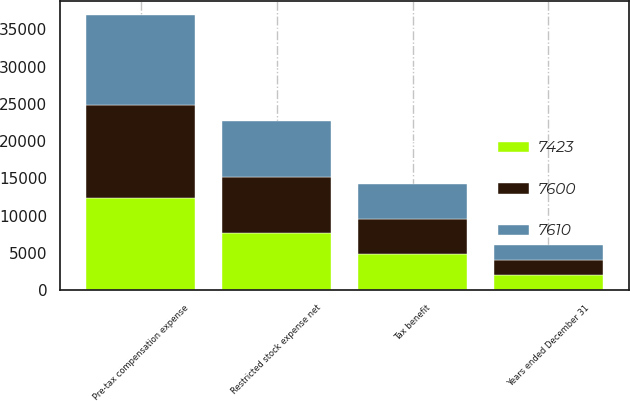Convert chart to OTSL. <chart><loc_0><loc_0><loc_500><loc_500><stacked_bar_chart><ecel><fcel>Years ended December 31<fcel>Pre-tax compensation expense<fcel>Tax benefit<fcel>Restricted stock expense net<nl><fcel>7600<fcel>2017<fcel>12399<fcel>4799<fcel>7600<nl><fcel>7423<fcel>2016<fcel>12415<fcel>4805<fcel>7610<nl><fcel>7610<fcel>2015<fcel>12110<fcel>4687<fcel>7423<nl></chart> 